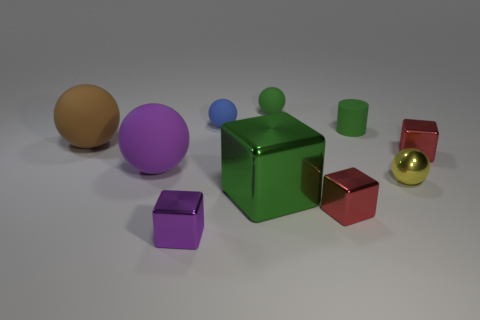Subtract all yellow cylinders. How many red cubes are left? 2 Subtract all matte balls. How many balls are left? 1 Subtract 3 balls. How many balls are left? 2 Subtract all purple balls. How many balls are left? 4 Subtract all blocks. How many objects are left? 6 Subtract 0 blue blocks. How many objects are left? 10 Subtract all brown cubes. Subtract all brown balls. How many cubes are left? 4 Subtract all tiny yellow cylinders. Subtract all large balls. How many objects are left? 8 Add 3 brown things. How many brown things are left? 4 Add 5 tiny gray balls. How many tiny gray balls exist? 5 